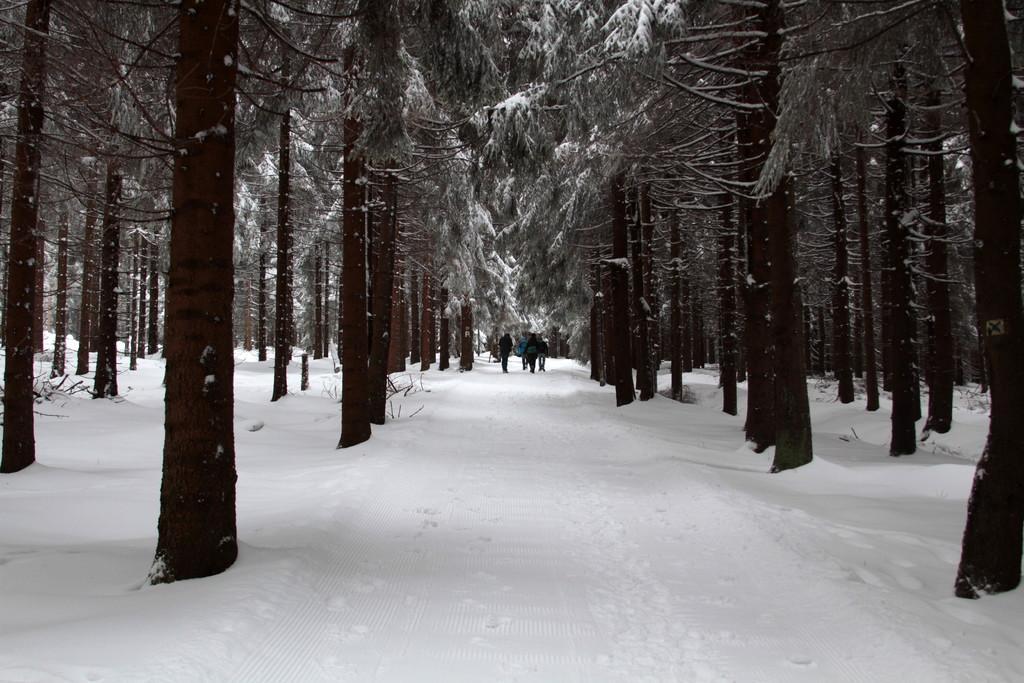How would you summarize this image in a sentence or two? In this image I can see the white colored snow on the ground, number of trees and few persons standing on the snow. 